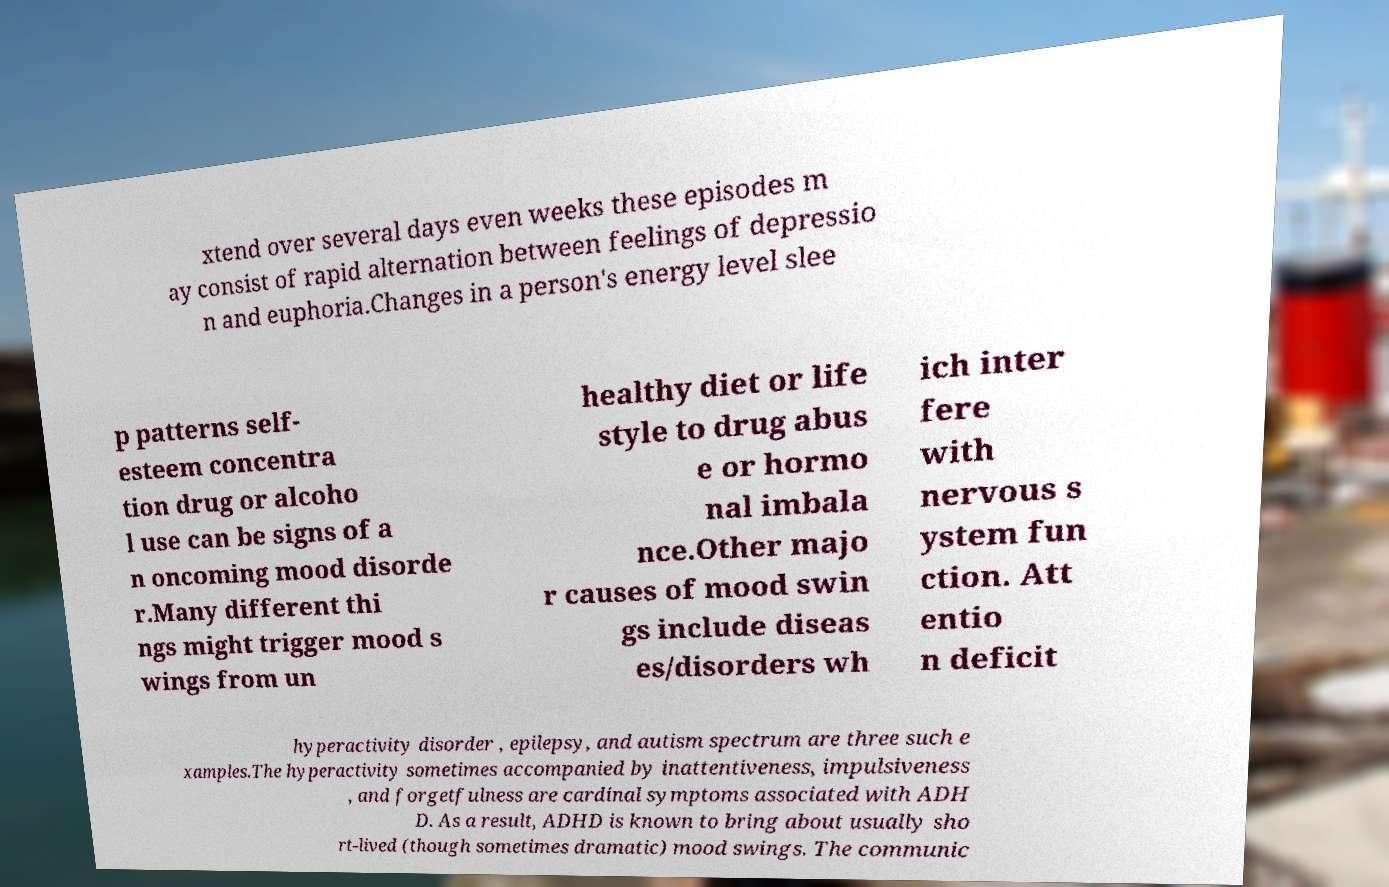There's text embedded in this image that I need extracted. Can you transcribe it verbatim? xtend over several days even weeks these episodes m ay consist of rapid alternation between feelings of depressio n and euphoria.Changes in a person's energy level slee p patterns self- esteem concentra tion drug or alcoho l use can be signs of a n oncoming mood disorde r.Many different thi ngs might trigger mood s wings from un healthy diet or life style to drug abus e or hormo nal imbala nce.Other majo r causes of mood swin gs include diseas es/disorders wh ich inter fere with nervous s ystem fun ction. Att entio n deficit hyperactivity disorder , epilepsy, and autism spectrum are three such e xamples.The hyperactivity sometimes accompanied by inattentiveness, impulsiveness , and forgetfulness are cardinal symptoms associated with ADH D. As a result, ADHD is known to bring about usually sho rt-lived (though sometimes dramatic) mood swings. The communic 